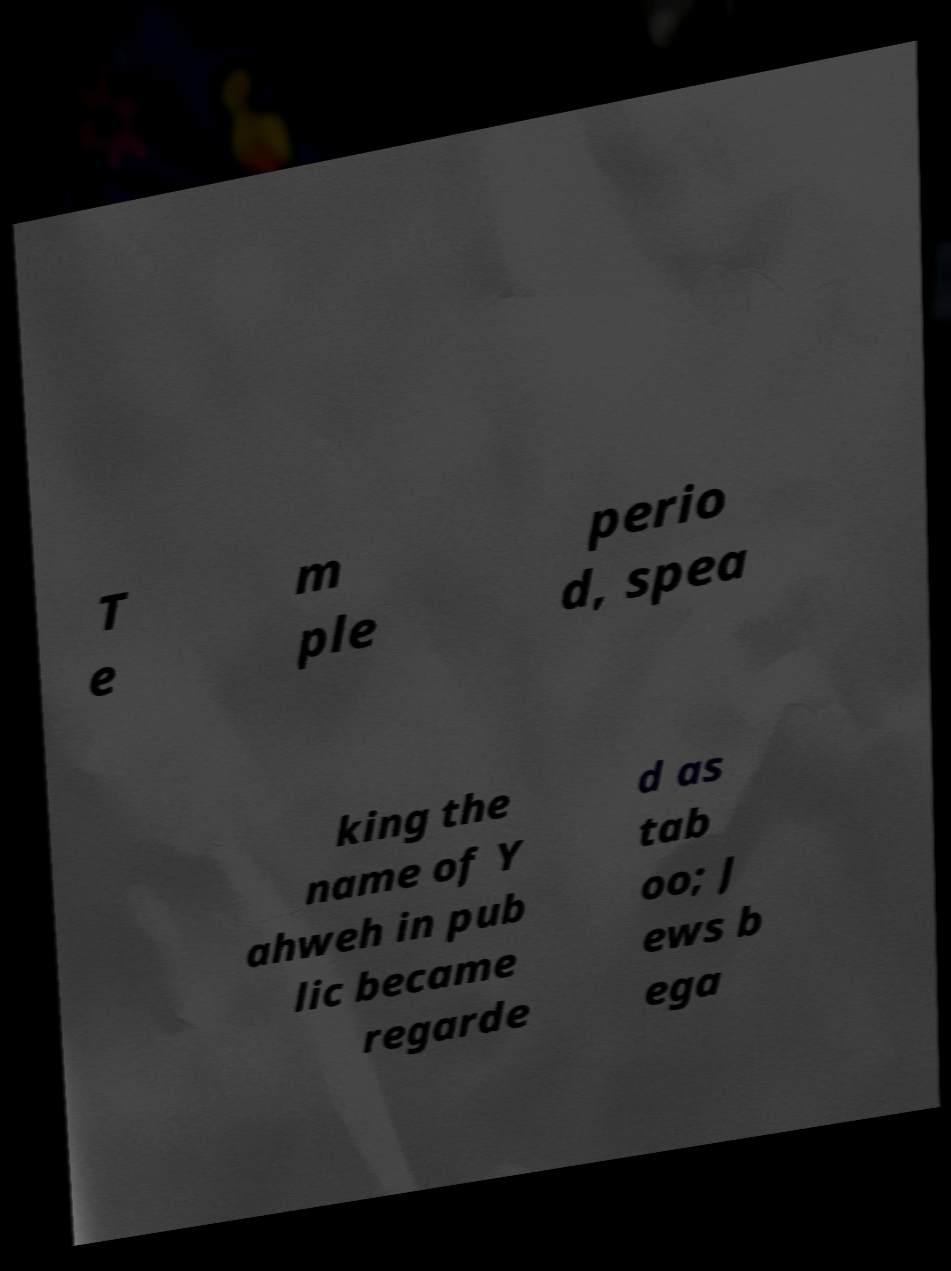Can you accurately transcribe the text from the provided image for me? T e m ple perio d, spea king the name of Y ahweh in pub lic became regarde d as tab oo; J ews b ega 